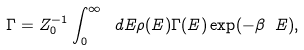<formula> <loc_0><loc_0><loc_500><loc_500>\Gamma = Z _ { 0 } ^ { - 1 } \int _ { 0 } ^ { \infty } \ d E \rho ( E ) \Gamma ( E ) \exp ( - \beta \ E ) ,</formula> 